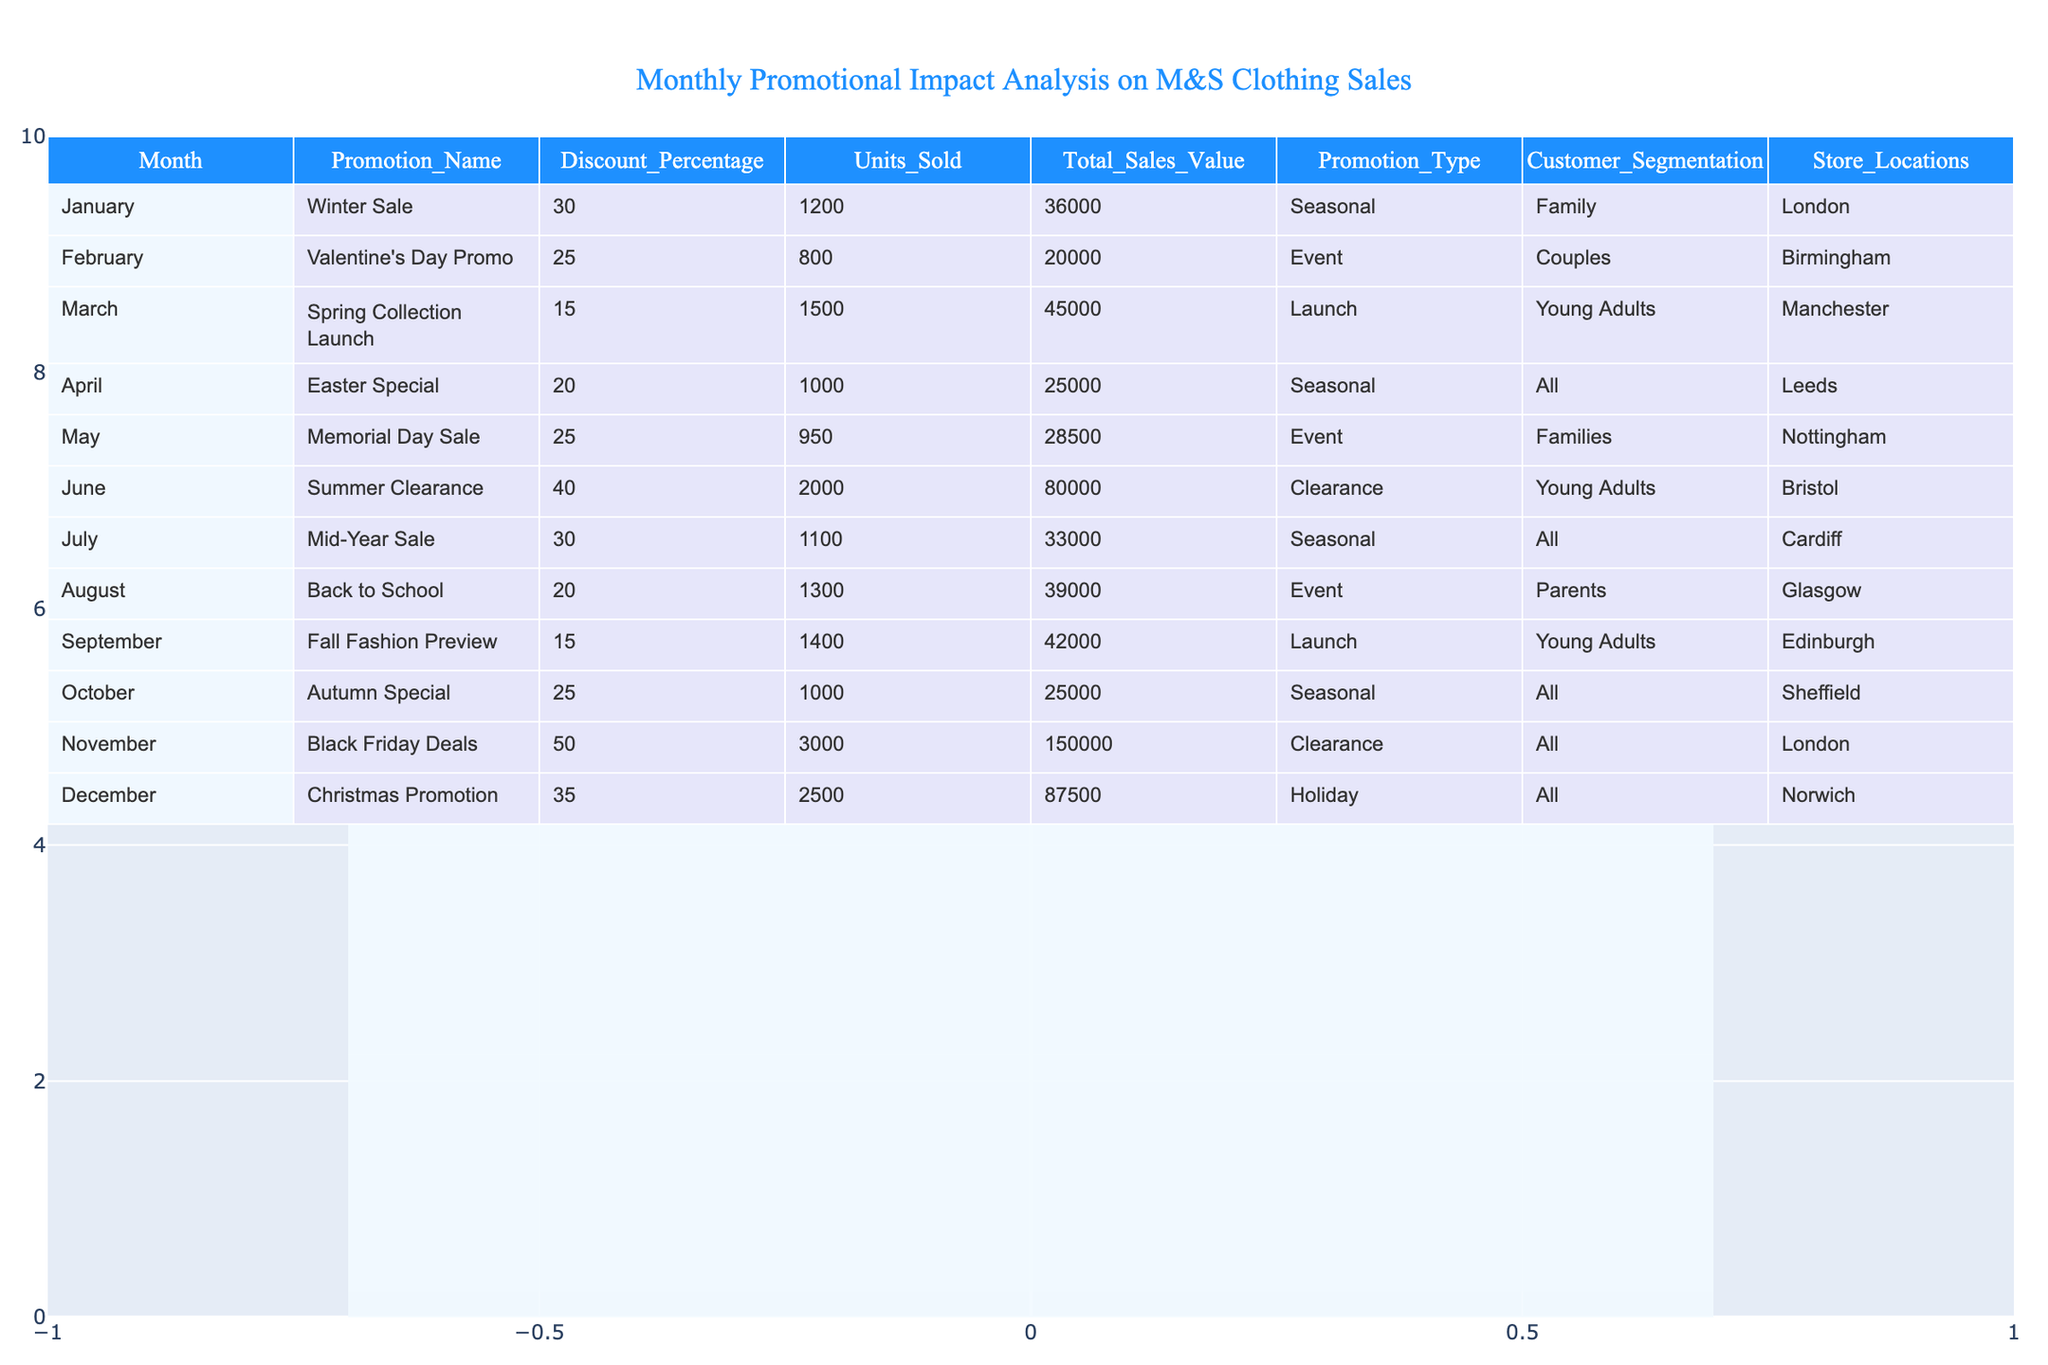What was the highest discount percentage in the promotions? The table shows the discount percentages for each promotion. Scanning through the values, the highest discount percentage is 50%, which corresponds to the Black Friday Deals in November.
Answer: 50% Which month had the lowest total sales value? By looking at the 'Total_Sales_Value' column, the lowest value is 20,000 for the Valentine's Day Promo in February.
Answer: 20,000 How many units were sold in June? The table indicates that 2,000 units were sold during the Summer Clearance promotion in June.
Answer: 2,000 What is the average total sales value across all promotions? Adding together all 'Total_Sales_Value' amounts: 36,000 + 20,000 + 45,000 + 25,000 + 28,500 + 80,000 + 33,000 + 39,000 + 42,000 + 25,000 + 150,000 + 87,500 =  588,000. There are 12 promotions, so the average is 588,000 / 12 = 49,000.
Answer: 49,000 Which promotion type generated the most units sold? Looking at the 'Units_Sold' for each promotion type, the Black Friday Deals led with 3,000 units sold.
Answer: Black Friday Deals Was there a promotion in April that offered more than 20% discount? The Easter Special in April provided a discount of 20%, so it does not exceed the threshold; therefore, there was no promotion with a discount over 20%.
Answer: No Did the Christmas Promotion have the greatest total sales value compared to any other month? Comparing 'Total_Sales_Value', Christmas Promotion recorded 87,500, while the Black Friday Deals reached 150,000. Since 150,000 is higher, Christmas did not have the greatest value.
Answer: No How do the units sold in October compare to those sold in January? October had 1,000 units sold for the Autumn Special, while January had 1,200 from the Winter Sale. Since 1,200 is greater than 1,000, January had more units sold.
Answer: January had more units sold Which month had promotions targeting young adults? Young adults were targeted in March (Spring Collection Launch), June (Summer Clearance), September (Fall Fashion Preview), making it three months focused on this segmentation.
Answer: Three months What is the difference in total sales value between the highest and lowest promotions? The highest total sales value is from Black Friday Deals at 150,000, and the lowest is Valentine's Day Promo at 20,000. The difference is 150,000 - 20,000 = 130,000.
Answer: 130,000 